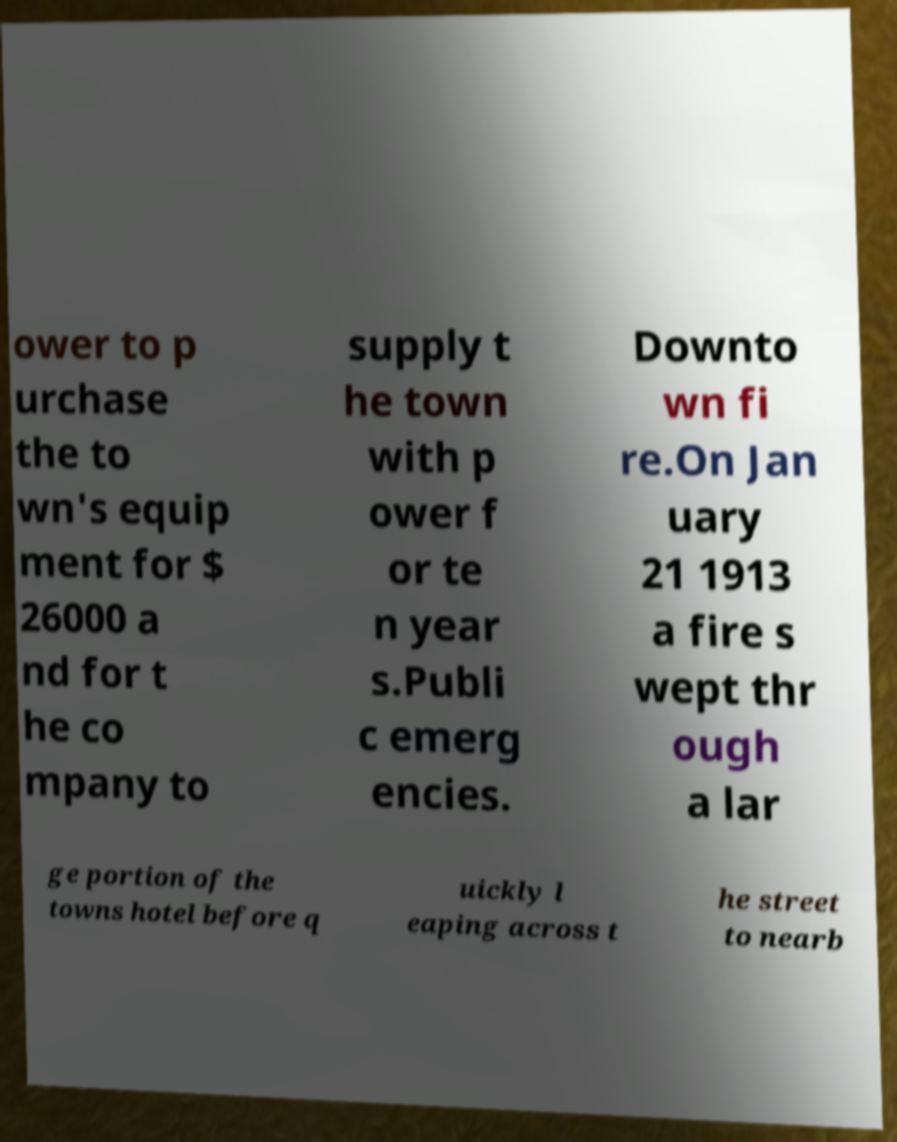I need the written content from this picture converted into text. Can you do that? ower to p urchase the to wn's equip ment for $ 26000 a nd for t he co mpany to supply t he town with p ower f or te n year s.Publi c emerg encies. Downto wn fi re.On Jan uary 21 1913 a fire s wept thr ough a lar ge portion of the towns hotel before q uickly l eaping across t he street to nearb 